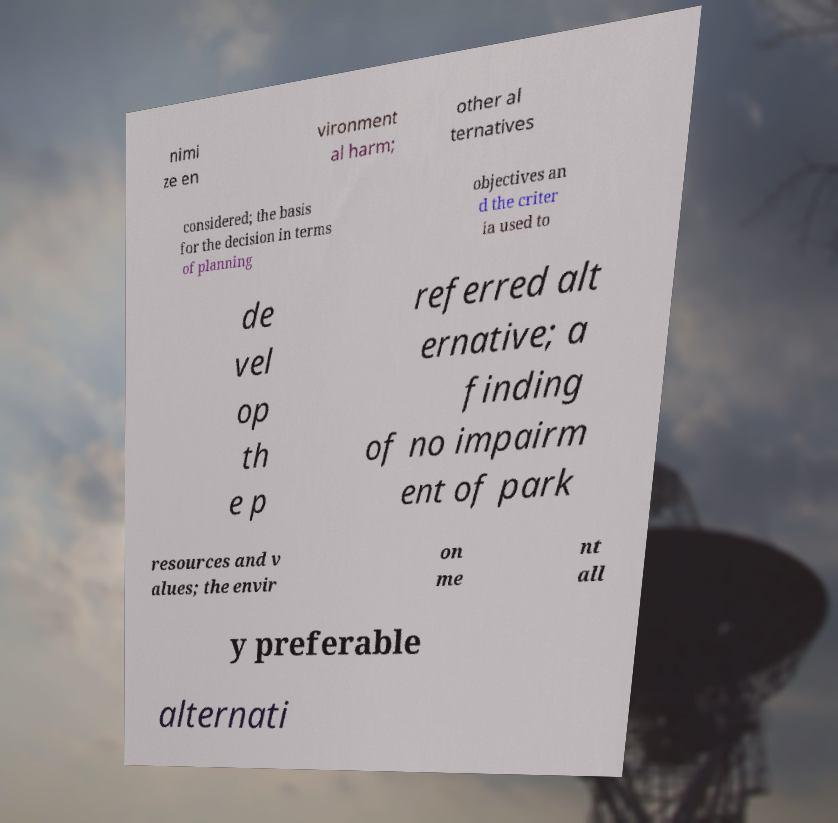There's text embedded in this image that I need extracted. Can you transcribe it verbatim? nimi ze en vironment al harm; other al ternatives considered; the basis for the decision in terms of planning objectives an d the criter ia used to de vel op th e p referred alt ernative; a finding of no impairm ent of park resources and v alues; the envir on me nt all y preferable alternati 